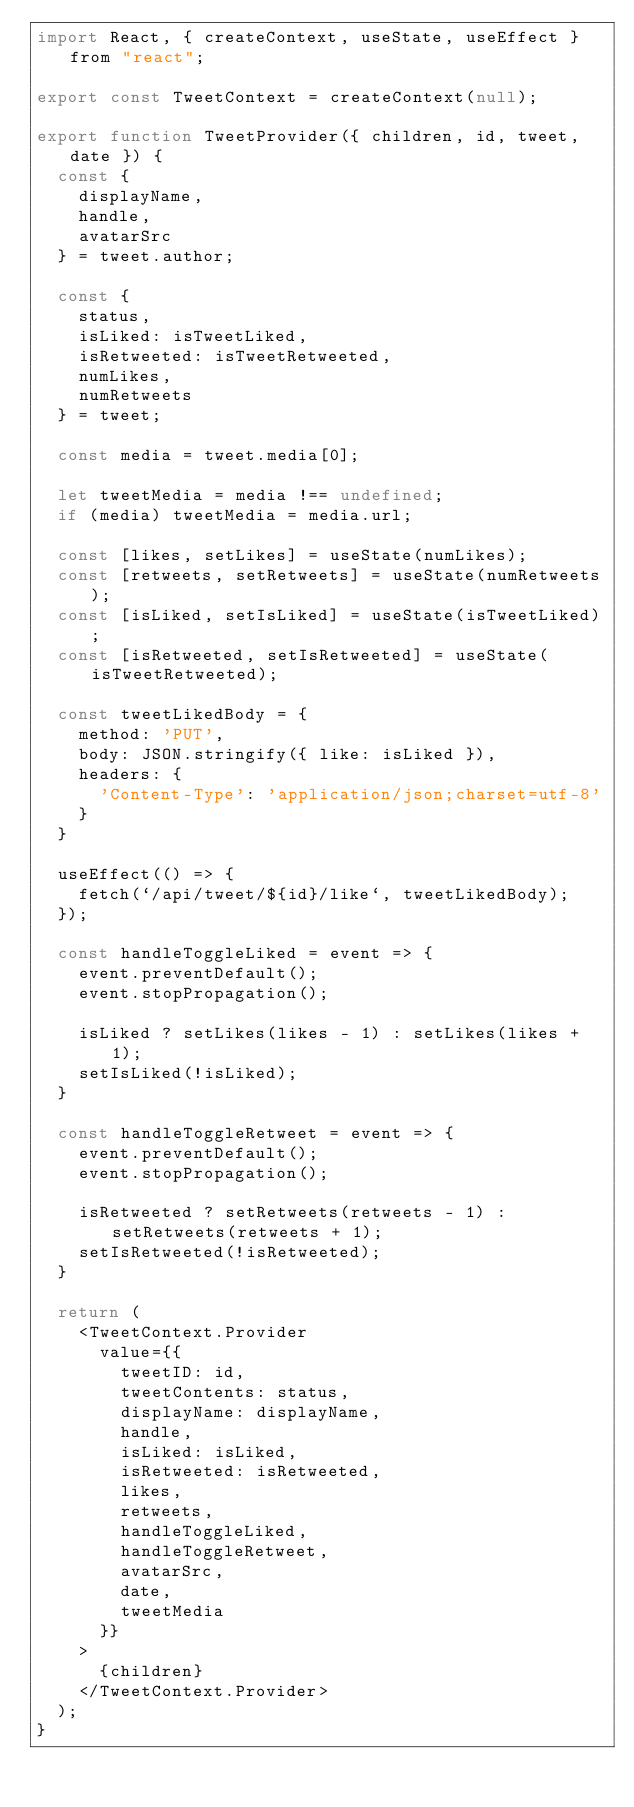<code> <loc_0><loc_0><loc_500><loc_500><_JavaScript_>import React, { createContext, useState, useEffect } from "react";

export const TweetContext = createContext(null);

export function TweetProvider({ children, id, tweet, date }) {
  const {
    displayName,
    handle,
    avatarSrc
  } = tweet.author;

  const {
    status,
    isLiked: isTweetLiked,
    isRetweeted: isTweetRetweeted,
    numLikes,
    numRetweets
  } = tweet;

  const media = tweet.media[0];

  let tweetMedia = media !== undefined;
  if (media) tweetMedia = media.url;

  const [likes, setLikes] = useState(numLikes);
  const [retweets, setRetweets] = useState(numRetweets);
  const [isLiked, setIsLiked] = useState(isTweetLiked);
  const [isRetweeted, setIsRetweeted] = useState(isTweetRetweeted);

  const tweetLikedBody = {
    method: 'PUT',
    body: JSON.stringify({ like: isLiked }),
    headers: {
      'Content-Type': 'application/json;charset=utf-8'
    }
  }

  useEffect(() => {
    fetch(`/api/tweet/${id}/like`, tweetLikedBody);
  });

  const handleToggleLiked = event => {
    event.preventDefault();
    event.stopPropagation();

    isLiked ? setLikes(likes - 1) : setLikes(likes + 1);
    setIsLiked(!isLiked);
  }

  const handleToggleRetweet = event => {
    event.preventDefault();
    event.stopPropagation();

    isRetweeted ? setRetweets(retweets - 1) : setRetweets(retweets + 1);
    setIsRetweeted(!isRetweeted);
  }

  return (
    <TweetContext.Provider
      value={{
        tweetID: id,
        tweetContents: status,
        displayName: displayName,
        handle,
        isLiked: isLiked,
        isRetweeted: isRetweeted,
        likes,
        retweets,
        handleToggleLiked,
        handleToggleRetweet,
        avatarSrc,
        date,
        tweetMedia
      }}
    >
      {children}
    </TweetContext.Provider>
  );
}
</code> 